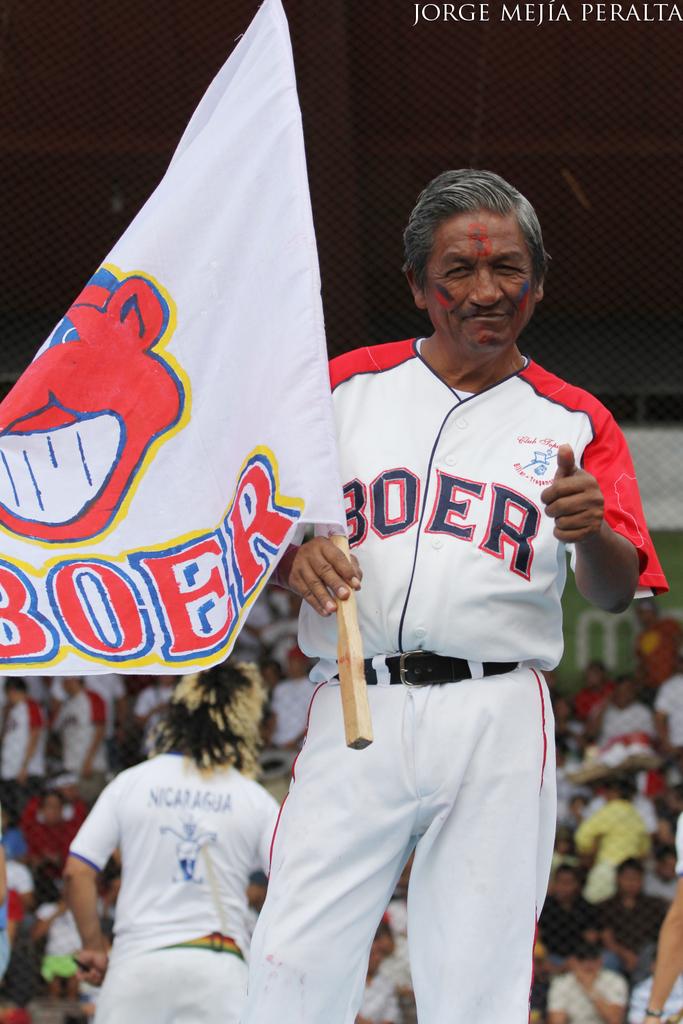What team does this man play for?
Your response must be concise. Boer. What country's name is written on the man in the back's jersey?
Your answer should be very brief. Nicaragua. 